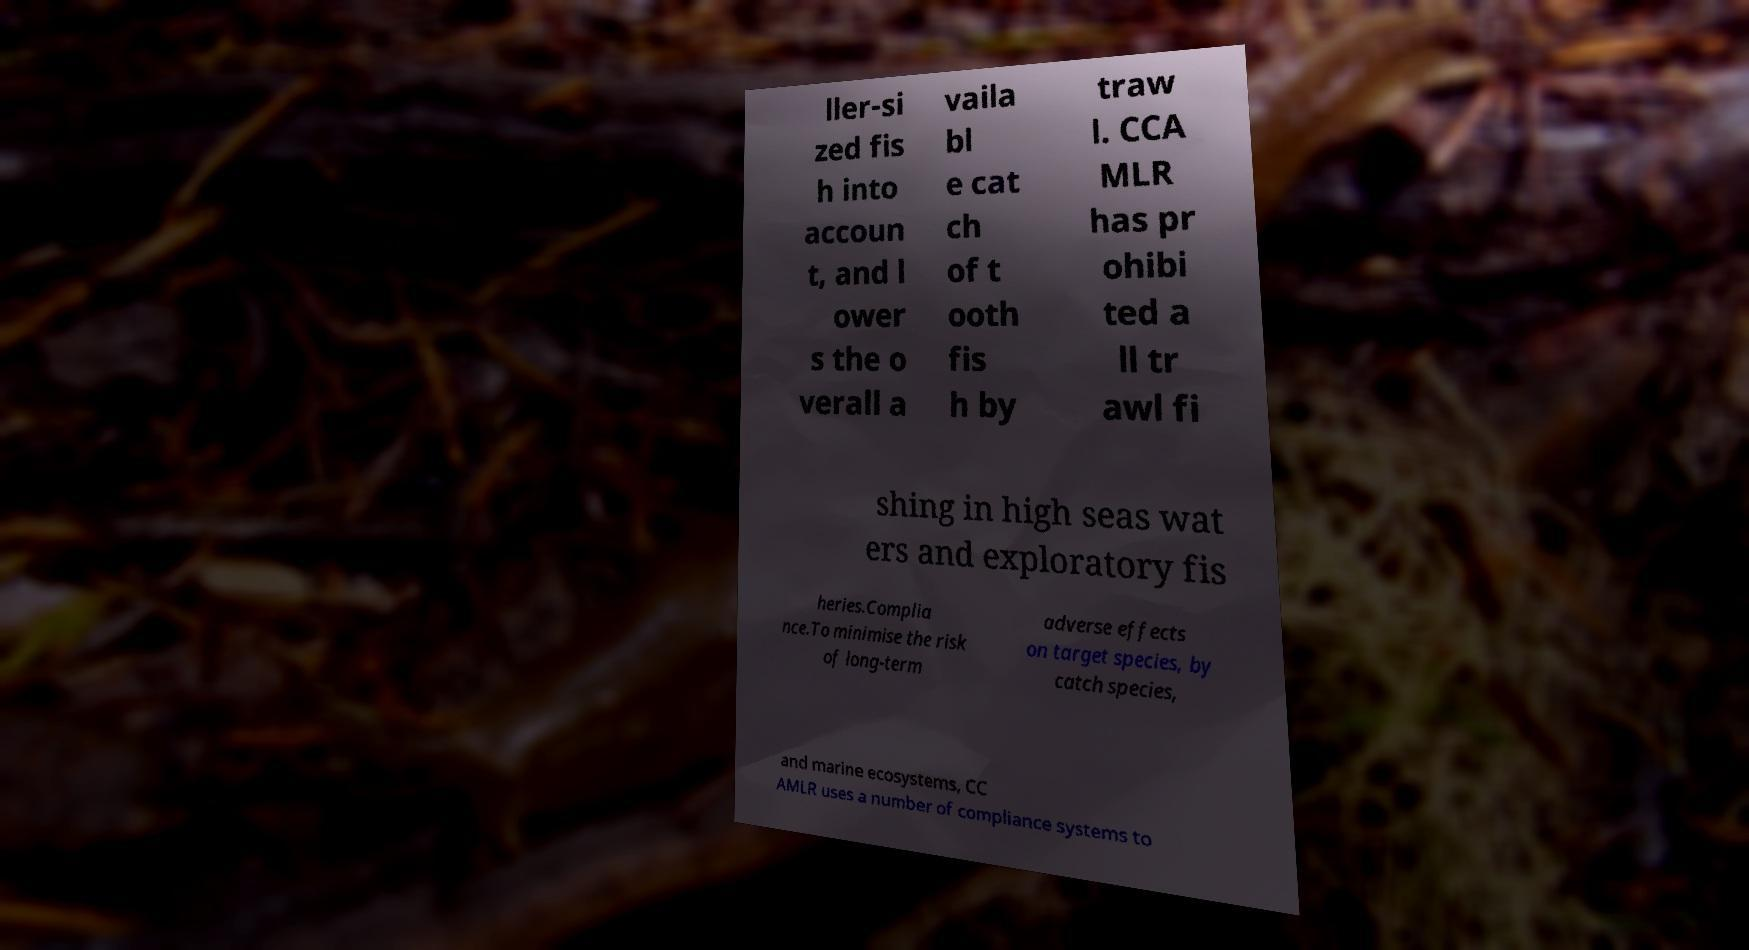Please identify and transcribe the text found in this image. ller-si zed fis h into accoun t, and l ower s the o verall a vaila bl e cat ch of t ooth fis h by traw l. CCA MLR has pr ohibi ted a ll tr awl fi shing in high seas wat ers and exploratory fis heries.Complia nce.To minimise the risk of long-term adverse effects on target species, by catch species, and marine ecosystems, CC AMLR uses a number of compliance systems to 